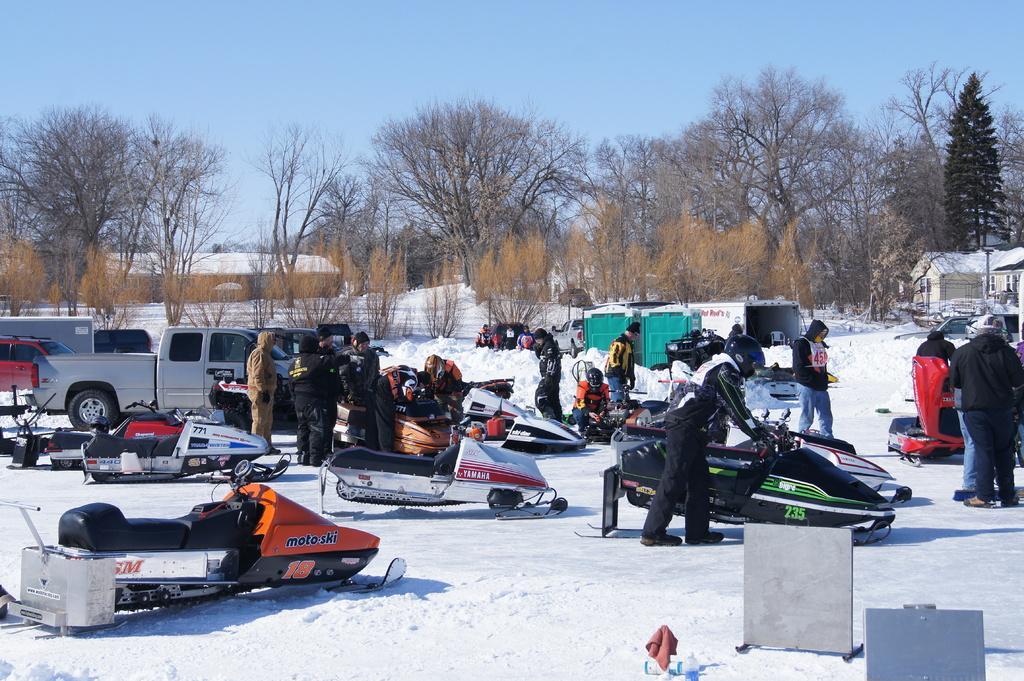Describe this image in one or two sentences. In this image, we can see snow on the ground, we can see some snowmobiles, there are some people standing, we can see some cars, there are some trees, at the top we can see the blue sky. 